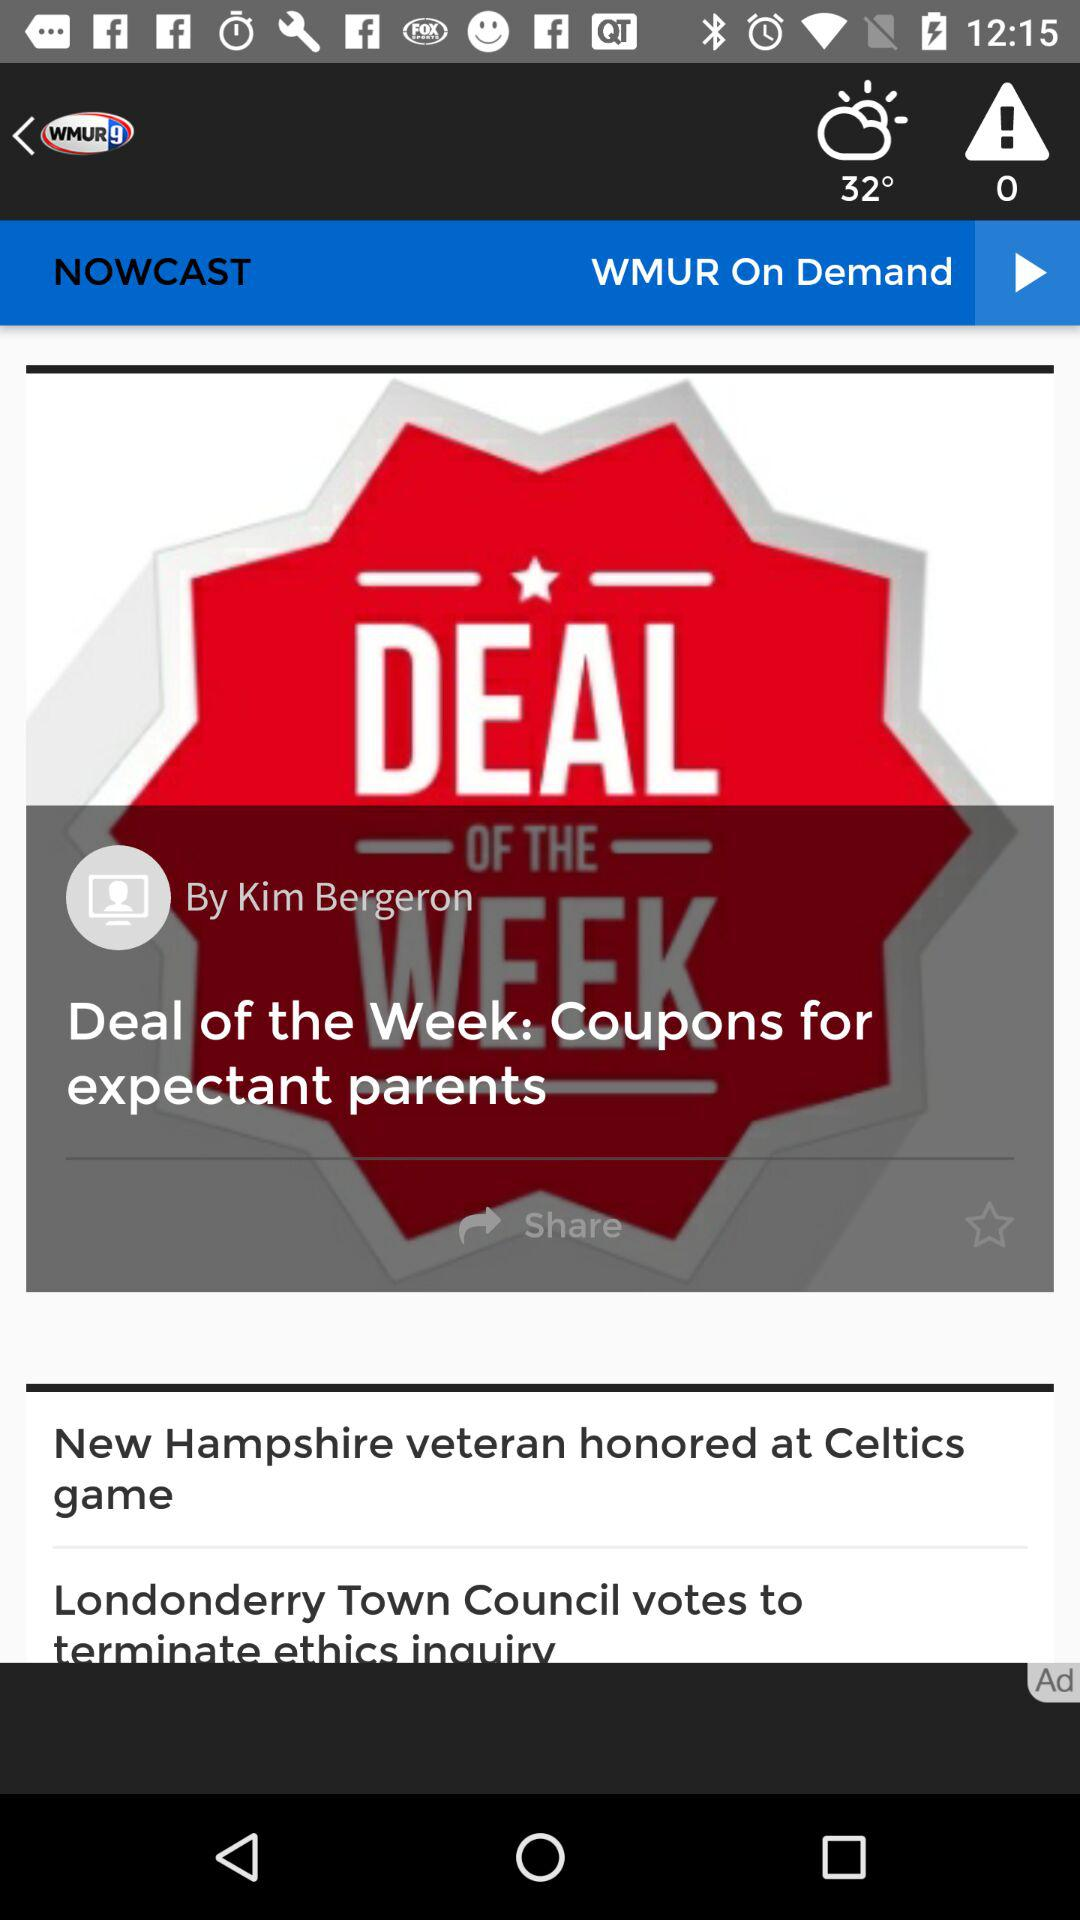Who is the writer? The writer is Kim Bergeron. 